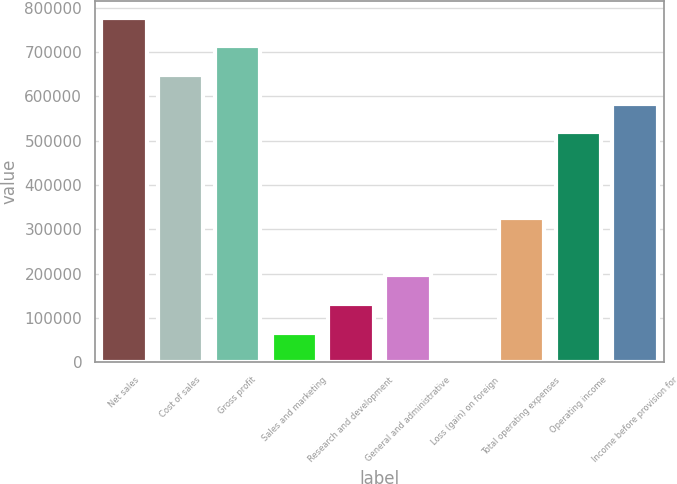Convert chart. <chart><loc_0><loc_0><loc_500><loc_500><bar_chart><fcel>Net sales<fcel>Cost of sales<fcel>Gross profit<fcel>Sales and marketing<fcel>Research and development<fcel>General and administrative<fcel>Loss (gain) on foreign<fcel>Total operating expenses<fcel>Operating income<fcel>Income before provision for<nl><fcel>777134<fcel>648034<fcel>712584<fcel>67085.8<fcel>131636<fcel>196185<fcel>2536<fcel>325285<fcel>518934<fcel>583484<nl></chart> 